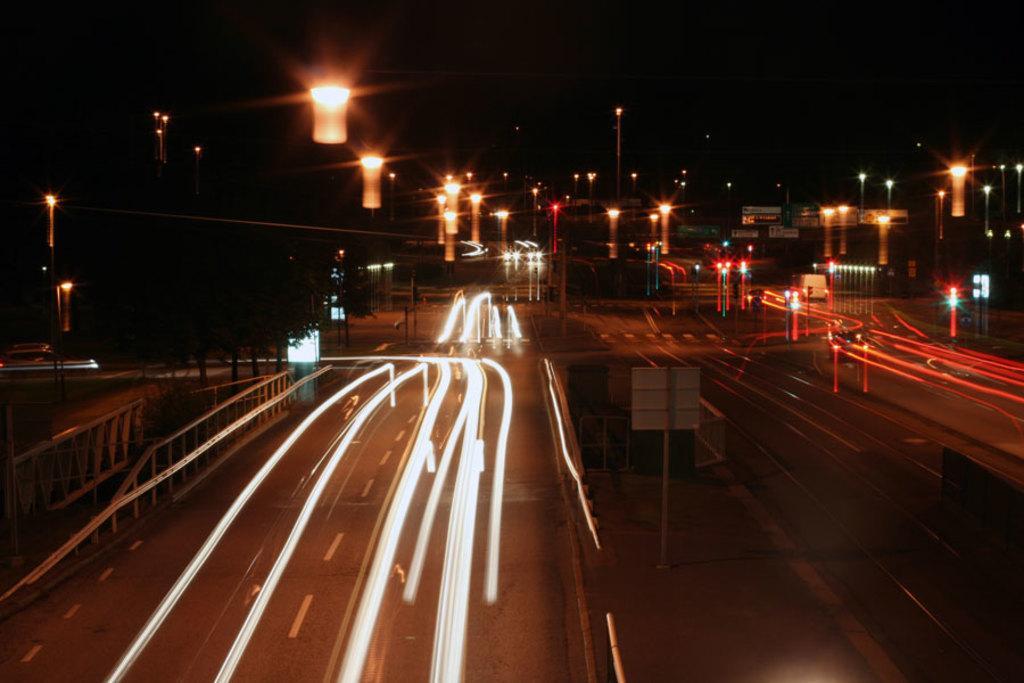Please provide a concise description of this image. In the picture we can see a night view of the roads with lights and in the background, we can see street lights with poles and behind it we can see a sky which is dark. 